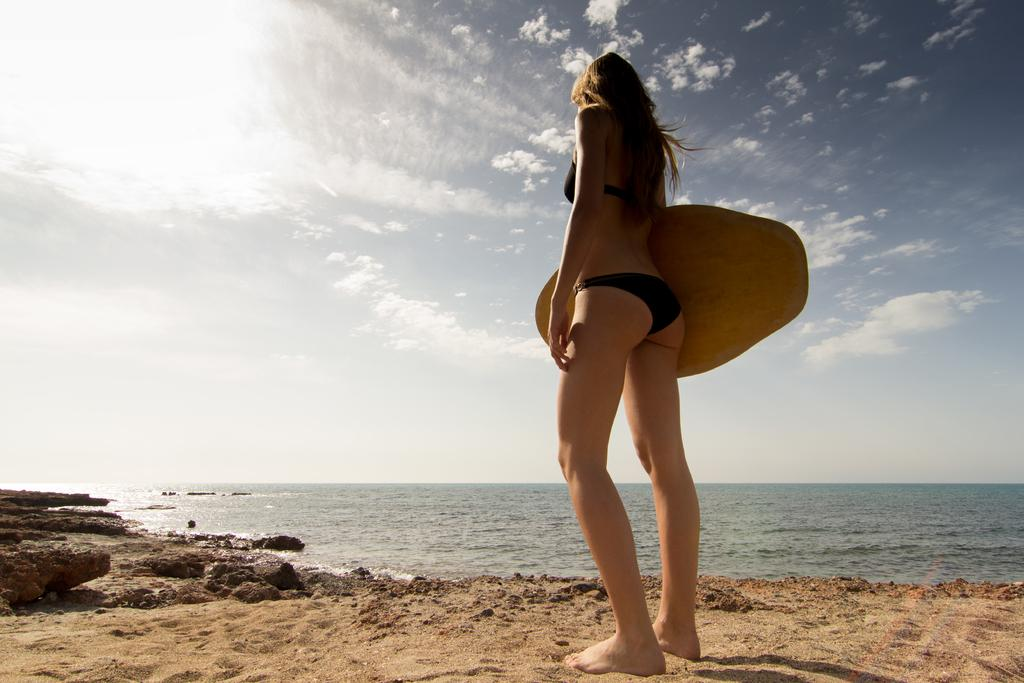Who is present in the image? There is a woman in the image. Where is the woman located? The woman is standing on a beach. What structure can be seen in the image? There is a diving board in the image. How would you describe the weather based on the image? The sky is cloudy in the image. What type of class is the woman attending in the image? There is no indication of a class or any educational activity in the image. Can you see a receipt in the woman's hand in the image? There is no receipt visible in the woman's hand or anywhere else in the image. 